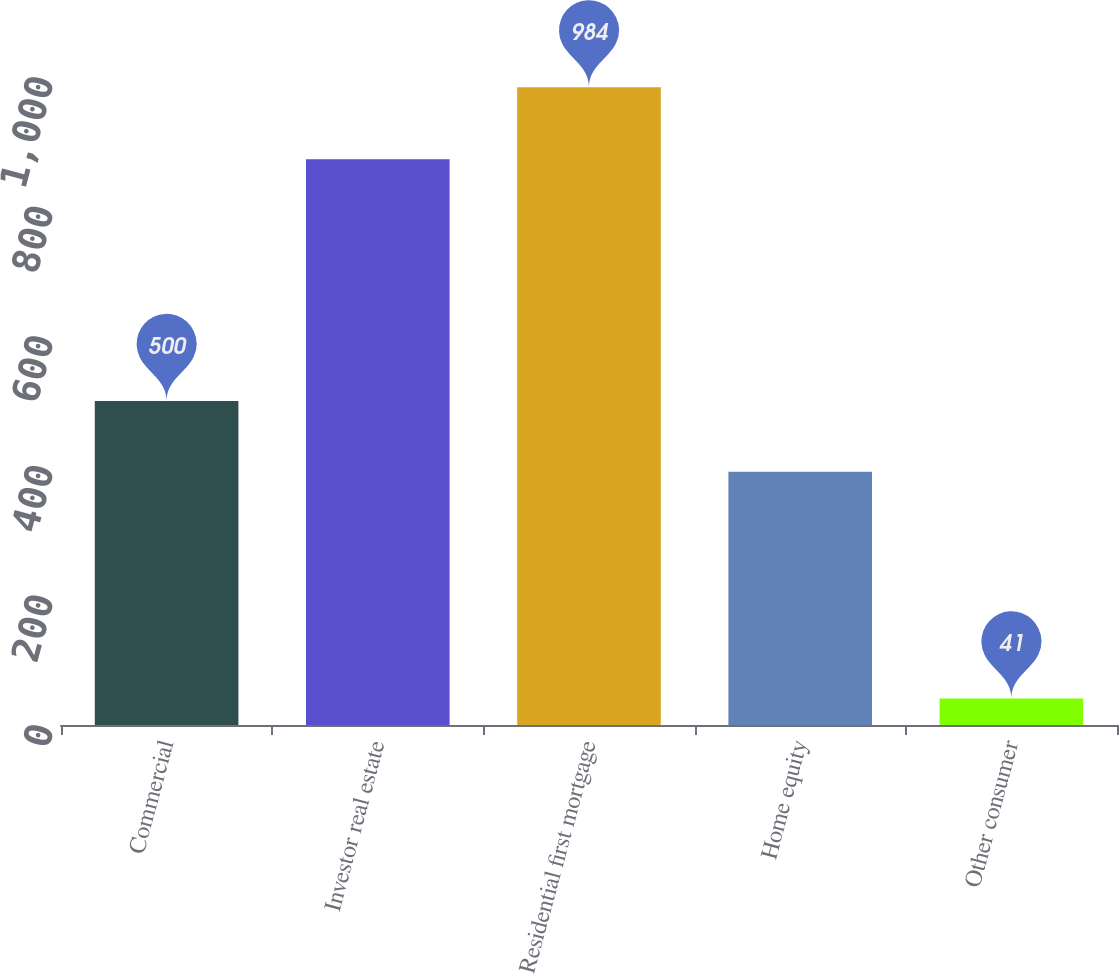<chart> <loc_0><loc_0><loc_500><loc_500><bar_chart><fcel>Commercial<fcel>Investor real estate<fcel>Residential first mortgage<fcel>Home equity<fcel>Other consumer<nl><fcel>500<fcel>873<fcel>984<fcel>391<fcel>41<nl></chart> 